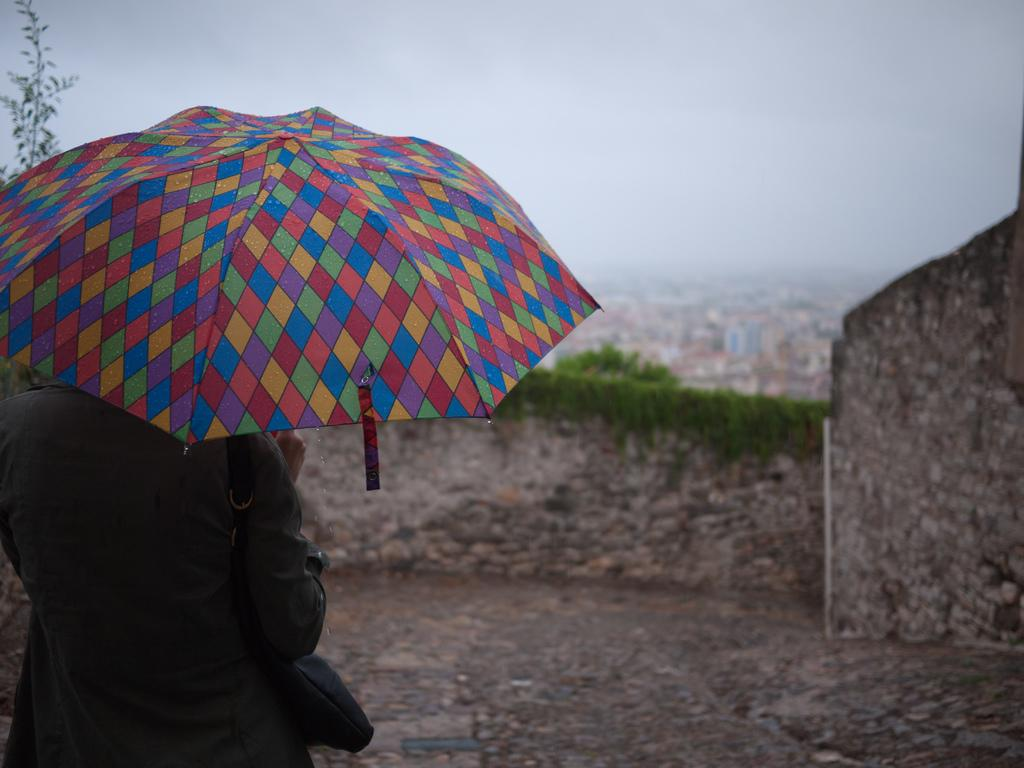What can be seen in the image? There is a person in the image. What is the person holding? The person is holding a multi-color umbrella and a handbag. What is visible in the background of the image? There is a wall and buildings visible in the background. How would you describe the weather based on the image? The sky is cloudy in the image. How does the person in the image support the division of tasks? There is no information about the person's role in task division in the image. 